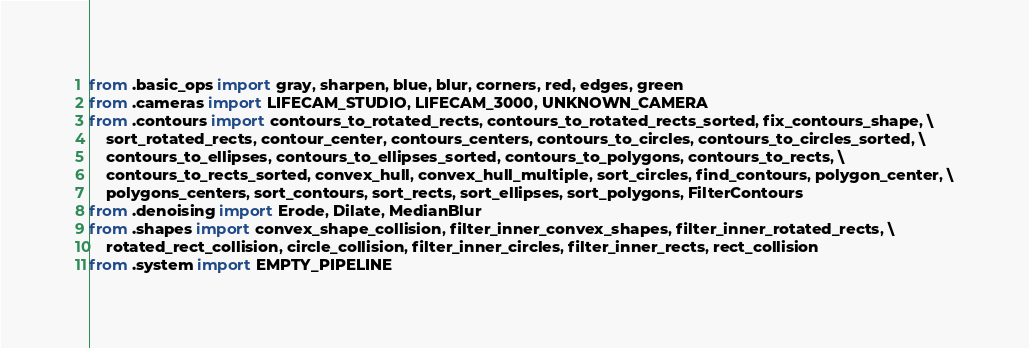<code> <loc_0><loc_0><loc_500><loc_500><_Python_>from .basic_ops import gray, sharpen, blue, blur, corners, red, edges, green
from .cameras import LIFECAM_STUDIO, LIFECAM_3000, UNKNOWN_CAMERA
from .contours import contours_to_rotated_rects, contours_to_rotated_rects_sorted, fix_contours_shape, \
    sort_rotated_rects, contour_center, contours_centers, contours_to_circles, contours_to_circles_sorted, \
    contours_to_ellipses, contours_to_ellipses_sorted, contours_to_polygons, contours_to_rects, \
    contours_to_rects_sorted, convex_hull, convex_hull_multiple, sort_circles, find_contours, polygon_center, \
    polygons_centers, sort_contours, sort_rects, sort_ellipses, sort_polygons, FilterContours
from .denoising import Erode, Dilate, MedianBlur
from .shapes import convex_shape_collision, filter_inner_convex_shapes, filter_inner_rotated_rects, \
    rotated_rect_collision, circle_collision, filter_inner_circles, filter_inner_rects, rect_collision
from .system import EMPTY_PIPELINE
</code> 